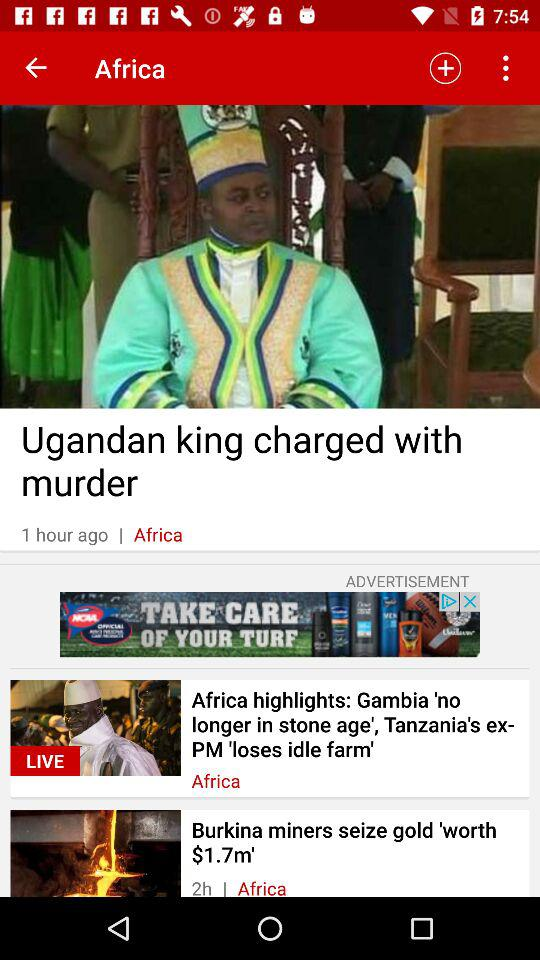How many hours ago was the first item published?
Answer the question using a single word or phrase. 1 